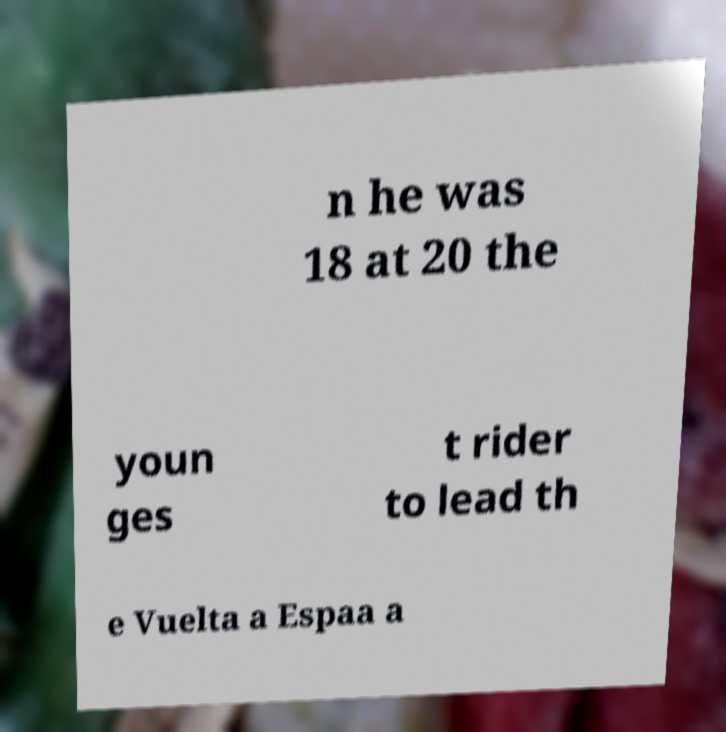For documentation purposes, I need the text within this image transcribed. Could you provide that? n he was 18 at 20 the youn ges t rider to lead th e Vuelta a Espaa a 